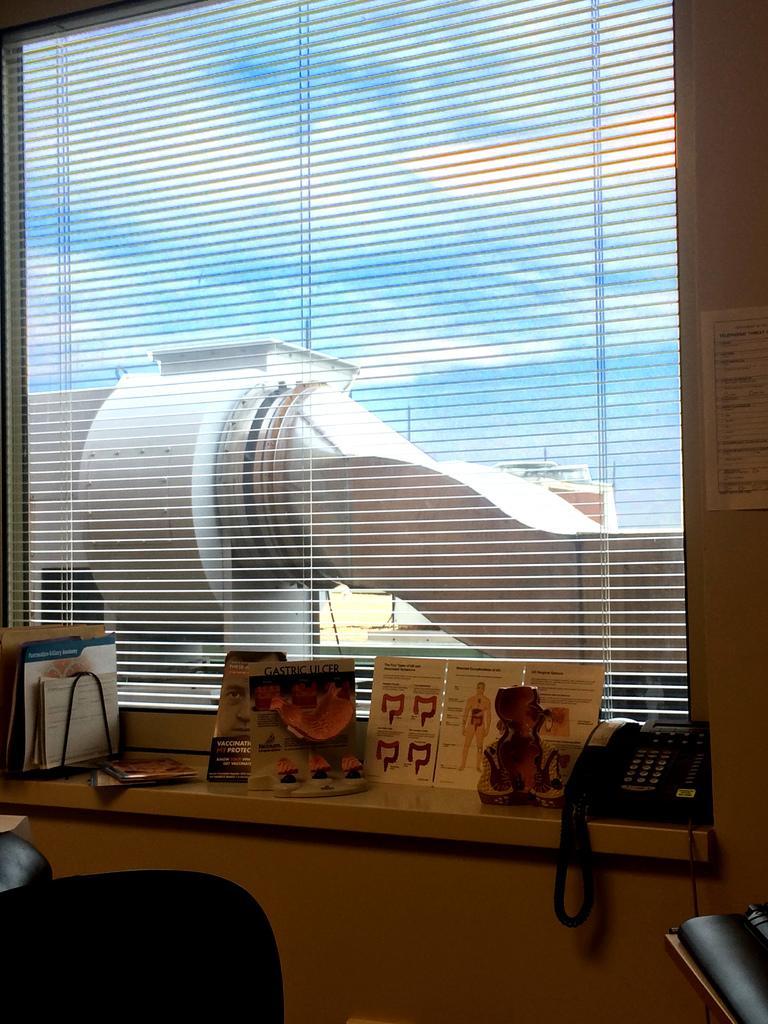Could you give a brief overview of what you see in this image? Here in this picture we can see a window covered with window flaps and out side we can see AC ducts and we can also see clouds in the sky and inside the room we can see a telephone, a statue and some books and papers present over there and on the left side we can see a chair present and right side on the wall we can see poster present over there. 